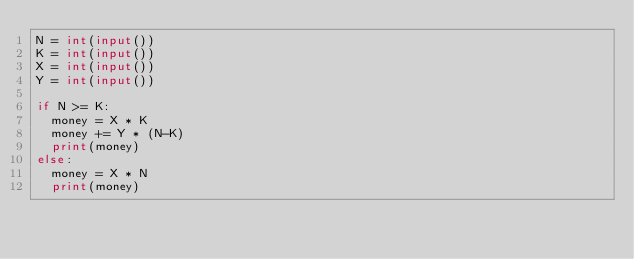<code> <loc_0><loc_0><loc_500><loc_500><_Python_>N = int(input())
K = int(input())
X = int(input())
Y = int(input())

if N >= K:
	money = X * K
	money += Y * (N-K)
	print(money)
else:
	money = X * N
	print(money)</code> 